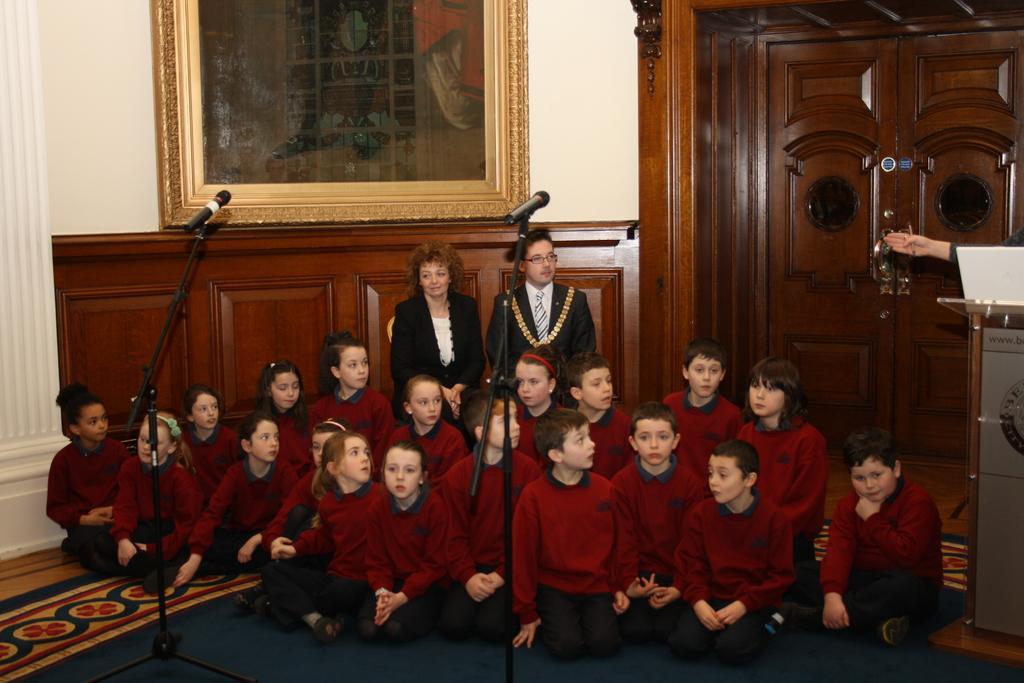Describe this image in one or two sentences. There are kids sitting on the floor and these two people sitting on chairs. On the right side of the image we can see a person hand and laptop above the podium. In the background we can see frame on a wall, cupboards and door. 